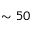<formula> <loc_0><loc_0><loc_500><loc_500>\sim 5 0</formula> 